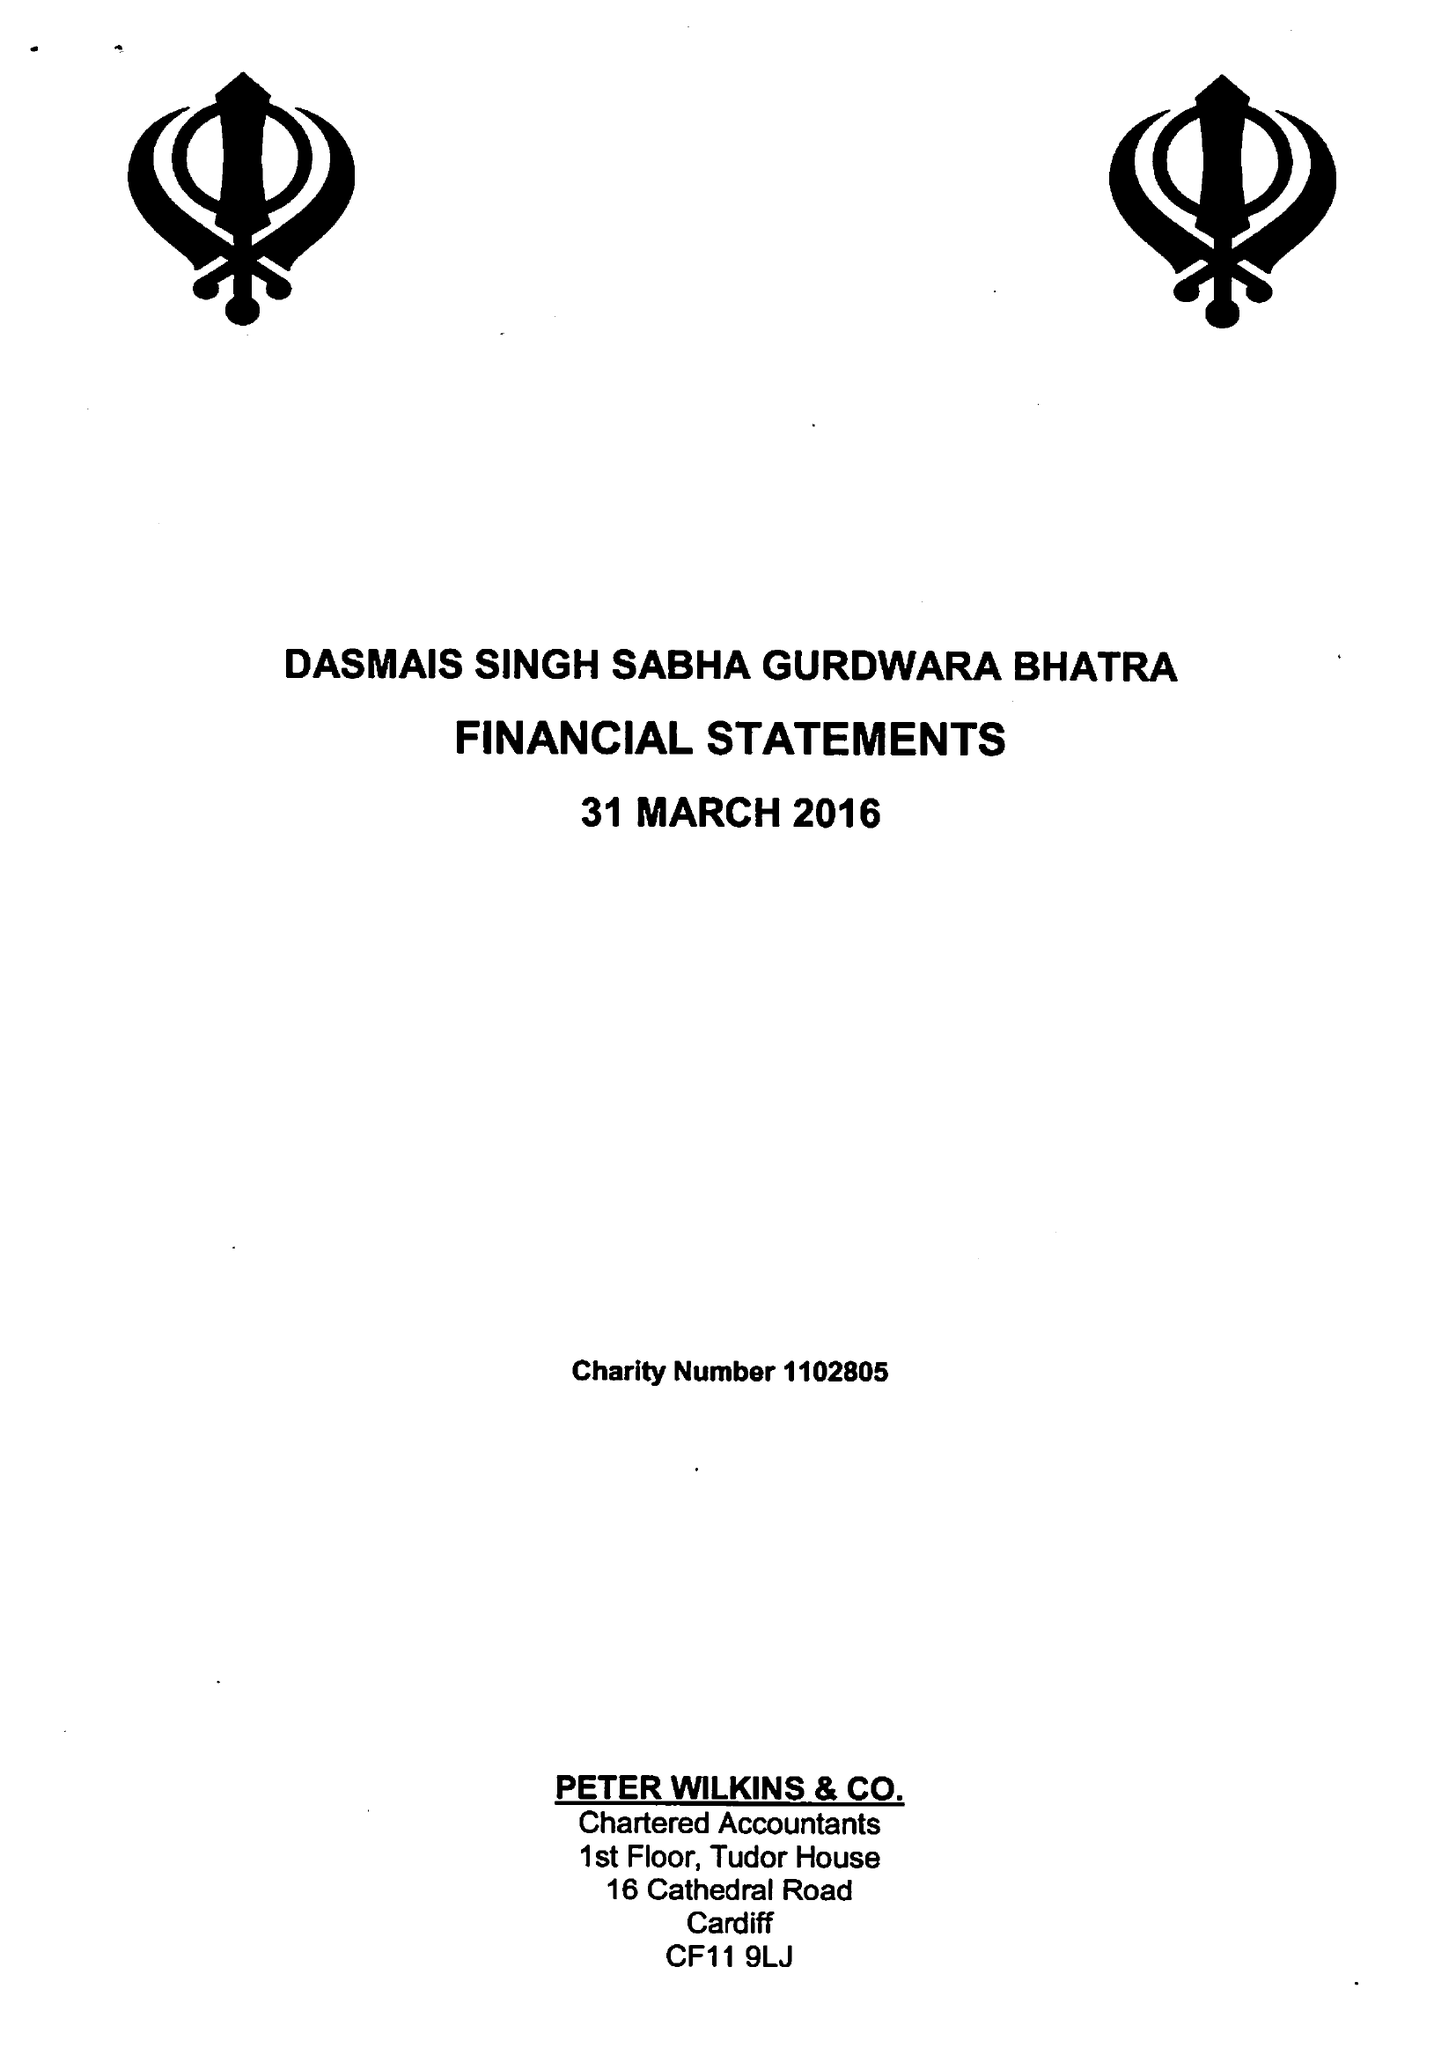What is the value for the charity_number?
Answer the question using a single word or phrase. 1102805 